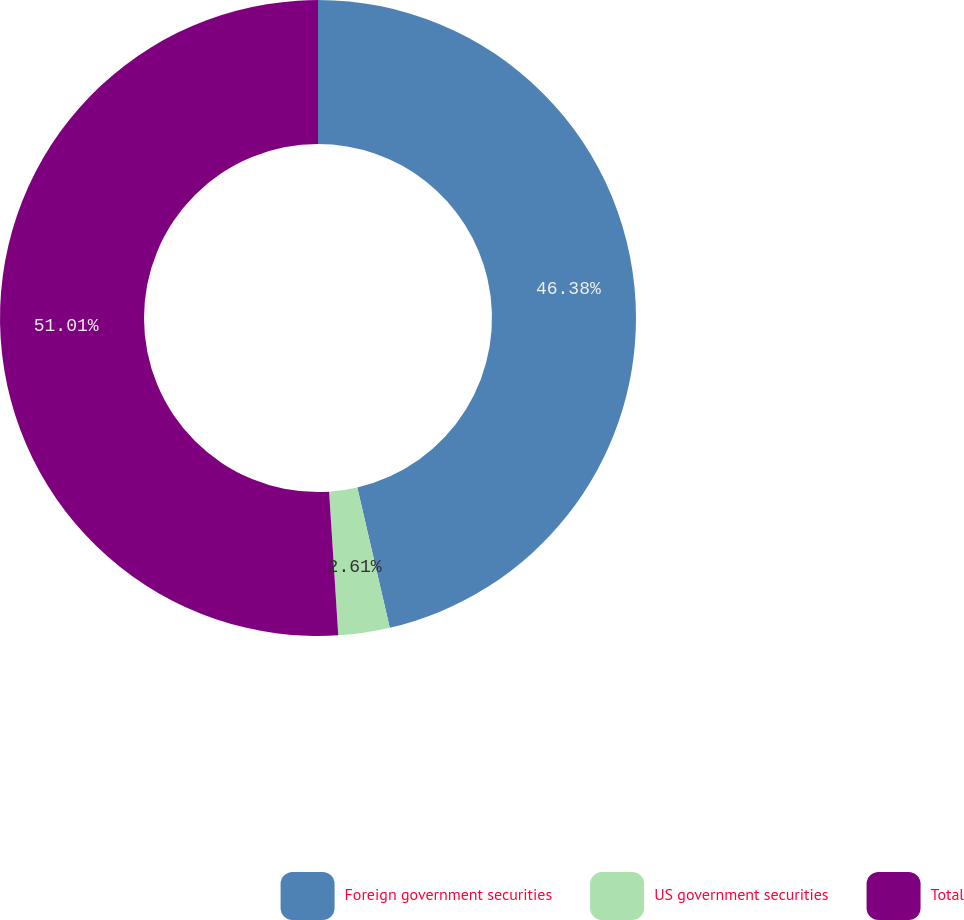Convert chart. <chart><loc_0><loc_0><loc_500><loc_500><pie_chart><fcel>Foreign government securities<fcel>US government securities<fcel>Total<nl><fcel>46.38%<fcel>2.61%<fcel>51.02%<nl></chart> 